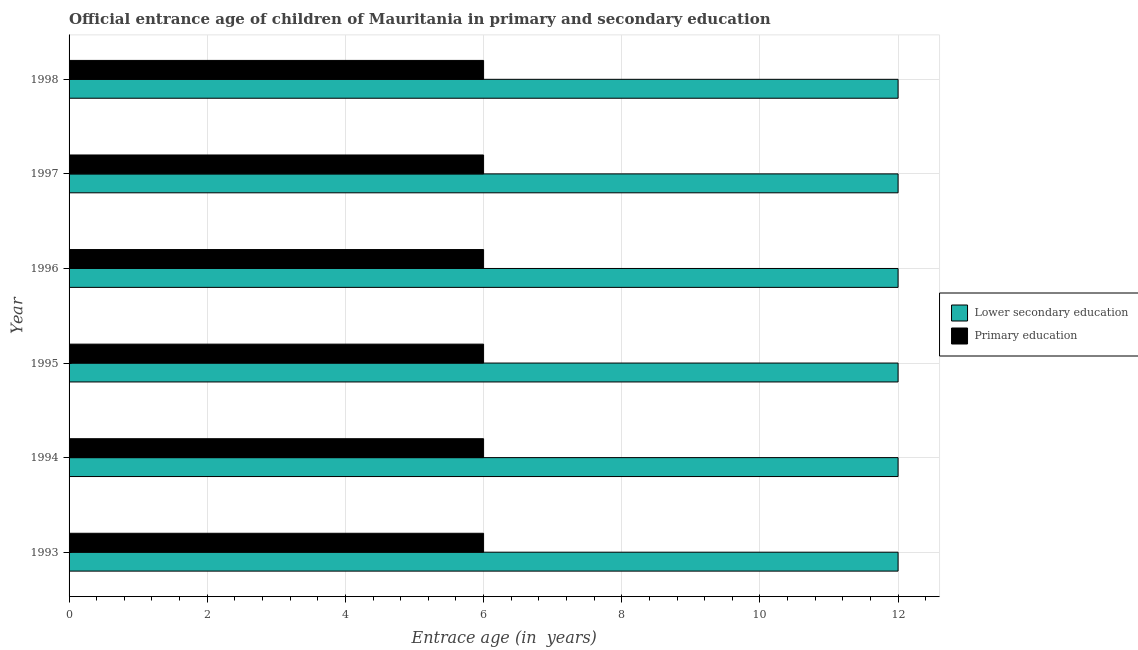How many different coloured bars are there?
Your answer should be compact. 2. How many groups of bars are there?
Provide a short and direct response. 6. Are the number of bars on each tick of the Y-axis equal?
Make the answer very short. Yes. How many bars are there on the 3rd tick from the bottom?
Keep it short and to the point. 2. What is the label of the 4th group of bars from the top?
Your answer should be very brief. 1995. What is the entrance age of children in lower secondary education in 1998?
Offer a very short reply. 12. Across all years, what is the maximum entrance age of chiildren in primary education?
Your answer should be compact. 6. Across all years, what is the minimum entrance age of chiildren in primary education?
Provide a succinct answer. 6. In which year was the entrance age of chiildren in primary education maximum?
Ensure brevity in your answer.  1993. In which year was the entrance age of children in lower secondary education minimum?
Your answer should be compact. 1993. What is the total entrance age of children in lower secondary education in the graph?
Give a very brief answer. 72. What is the difference between the entrance age of children in lower secondary education in 1996 and that in 1997?
Provide a short and direct response. 0. What is the difference between the entrance age of children in lower secondary education in 1994 and the entrance age of chiildren in primary education in 1993?
Make the answer very short. 6. In the year 1993, what is the difference between the entrance age of chiildren in primary education and entrance age of children in lower secondary education?
Your response must be concise. -6. In how many years, is the entrance age of chiildren in primary education greater than 10 years?
Your answer should be very brief. 0. What is the ratio of the entrance age of chiildren in primary education in 1994 to that in 1997?
Ensure brevity in your answer.  1. Is the entrance age of chiildren in primary education in 1997 less than that in 1998?
Provide a short and direct response. No. What is the difference between the highest and the second highest entrance age of chiildren in primary education?
Offer a terse response. 0. What is the difference between the highest and the lowest entrance age of chiildren in primary education?
Offer a very short reply. 0. Is the sum of the entrance age of chiildren in primary education in 1994 and 1997 greater than the maximum entrance age of children in lower secondary education across all years?
Your response must be concise. No. What does the 1st bar from the bottom in 1993 represents?
Your response must be concise. Lower secondary education. Are all the bars in the graph horizontal?
Offer a very short reply. Yes. How many years are there in the graph?
Your response must be concise. 6. What is the difference between two consecutive major ticks on the X-axis?
Make the answer very short. 2. Does the graph contain grids?
Give a very brief answer. Yes. Where does the legend appear in the graph?
Make the answer very short. Center right. What is the title of the graph?
Provide a short and direct response. Official entrance age of children of Mauritania in primary and secondary education. Does "Current education expenditure" appear as one of the legend labels in the graph?
Offer a terse response. No. What is the label or title of the X-axis?
Your answer should be very brief. Entrace age (in  years). What is the Entrace age (in  years) in Lower secondary education in 1993?
Make the answer very short. 12. What is the Entrace age (in  years) of Lower secondary education in 1995?
Keep it short and to the point. 12. What is the Entrace age (in  years) in Primary education in 1996?
Your answer should be very brief. 6. What is the Entrace age (in  years) in Lower secondary education in 1997?
Keep it short and to the point. 12. What is the Entrace age (in  years) in Primary education in 1997?
Your response must be concise. 6. Across all years, what is the maximum Entrace age (in  years) of Primary education?
Make the answer very short. 6. Across all years, what is the minimum Entrace age (in  years) of Lower secondary education?
Provide a succinct answer. 12. Across all years, what is the minimum Entrace age (in  years) of Primary education?
Offer a terse response. 6. What is the total Entrace age (in  years) of Lower secondary education in the graph?
Keep it short and to the point. 72. What is the total Entrace age (in  years) in Primary education in the graph?
Your answer should be compact. 36. What is the difference between the Entrace age (in  years) of Lower secondary education in 1993 and that in 1994?
Give a very brief answer. 0. What is the difference between the Entrace age (in  years) in Primary education in 1993 and that in 1994?
Provide a succinct answer. 0. What is the difference between the Entrace age (in  years) of Primary education in 1993 and that in 1996?
Make the answer very short. 0. What is the difference between the Entrace age (in  years) of Primary education in 1993 and that in 1998?
Offer a very short reply. 0. What is the difference between the Entrace age (in  years) in Lower secondary education in 1994 and that in 1996?
Your answer should be compact. 0. What is the difference between the Entrace age (in  years) of Lower secondary education in 1994 and that in 1998?
Offer a terse response. 0. What is the difference between the Entrace age (in  years) in Primary education in 1994 and that in 1998?
Ensure brevity in your answer.  0. What is the difference between the Entrace age (in  years) in Lower secondary education in 1995 and that in 1996?
Your response must be concise. 0. What is the difference between the Entrace age (in  years) of Primary education in 1995 and that in 1997?
Ensure brevity in your answer.  0. What is the difference between the Entrace age (in  years) in Lower secondary education in 1995 and that in 1998?
Provide a succinct answer. 0. What is the difference between the Entrace age (in  years) of Lower secondary education in 1996 and that in 1997?
Provide a short and direct response. 0. What is the difference between the Entrace age (in  years) in Primary education in 1997 and that in 1998?
Offer a very short reply. 0. What is the difference between the Entrace age (in  years) in Lower secondary education in 1993 and the Entrace age (in  years) in Primary education in 1994?
Ensure brevity in your answer.  6. What is the difference between the Entrace age (in  years) of Lower secondary education in 1993 and the Entrace age (in  years) of Primary education in 1995?
Offer a terse response. 6. What is the difference between the Entrace age (in  years) of Lower secondary education in 1993 and the Entrace age (in  years) of Primary education in 1996?
Your answer should be compact. 6. What is the difference between the Entrace age (in  years) in Lower secondary education in 1993 and the Entrace age (in  years) in Primary education in 1997?
Keep it short and to the point. 6. What is the difference between the Entrace age (in  years) of Lower secondary education in 1993 and the Entrace age (in  years) of Primary education in 1998?
Your answer should be compact. 6. What is the difference between the Entrace age (in  years) in Lower secondary education in 1994 and the Entrace age (in  years) in Primary education in 1995?
Keep it short and to the point. 6. What is the difference between the Entrace age (in  years) in Lower secondary education in 1994 and the Entrace age (in  years) in Primary education in 1997?
Make the answer very short. 6. What is the difference between the Entrace age (in  years) of Lower secondary education in 1994 and the Entrace age (in  years) of Primary education in 1998?
Ensure brevity in your answer.  6. What is the difference between the Entrace age (in  years) in Lower secondary education in 1995 and the Entrace age (in  years) in Primary education in 1996?
Your answer should be very brief. 6. What is the difference between the Entrace age (in  years) of Lower secondary education in 1995 and the Entrace age (in  years) of Primary education in 1998?
Offer a terse response. 6. What is the difference between the Entrace age (in  years) of Lower secondary education in 1996 and the Entrace age (in  years) of Primary education in 1998?
Make the answer very short. 6. What is the average Entrace age (in  years) of Primary education per year?
Your answer should be compact. 6. In the year 1996, what is the difference between the Entrace age (in  years) of Lower secondary education and Entrace age (in  years) of Primary education?
Offer a terse response. 6. In the year 1997, what is the difference between the Entrace age (in  years) in Lower secondary education and Entrace age (in  years) in Primary education?
Provide a short and direct response. 6. In the year 1998, what is the difference between the Entrace age (in  years) of Lower secondary education and Entrace age (in  years) of Primary education?
Your response must be concise. 6. What is the ratio of the Entrace age (in  years) in Primary education in 1993 to that in 1994?
Offer a very short reply. 1. What is the ratio of the Entrace age (in  years) in Primary education in 1993 to that in 1995?
Provide a succinct answer. 1. What is the ratio of the Entrace age (in  years) of Lower secondary education in 1993 to that in 1997?
Offer a very short reply. 1. What is the ratio of the Entrace age (in  years) in Primary education in 1994 to that in 1995?
Provide a succinct answer. 1. What is the ratio of the Entrace age (in  years) of Primary education in 1994 to that in 1996?
Your response must be concise. 1. What is the ratio of the Entrace age (in  years) of Lower secondary education in 1994 to that in 1997?
Your response must be concise. 1. What is the ratio of the Entrace age (in  years) in Primary education in 1994 to that in 1997?
Make the answer very short. 1. What is the ratio of the Entrace age (in  years) of Primary education in 1995 to that in 1996?
Make the answer very short. 1. What is the ratio of the Entrace age (in  years) in Lower secondary education in 1995 to that in 1997?
Your answer should be compact. 1. What is the ratio of the Entrace age (in  years) in Primary education in 1995 to that in 1997?
Offer a terse response. 1. What is the ratio of the Entrace age (in  years) in Lower secondary education in 1995 to that in 1998?
Provide a succinct answer. 1. What is the ratio of the Entrace age (in  years) in Primary education in 1996 to that in 1997?
Your response must be concise. 1. What is the ratio of the Entrace age (in  years) of Lower secondary education in 1996 to that in 1998?
Keep it short and to the point. 1. What is the ratio of the Entrace age (in  years) in Lower secondary education in 1997 to that in 1998?
Your answer should be compact. 1. What is the ratio of the Entrace age (in  years) of Primary education in 1997 to that in 1998?
Offer a very short reply. 1. What is the difference between the highest and the second highest Entrace age (in  years) in Primary education?
Ensure brevity in your answer.  0. What is the difference between the highest and the lowest Entrace age (in  years) of Lower secondary education?
Keep it short and to the point. 0. 